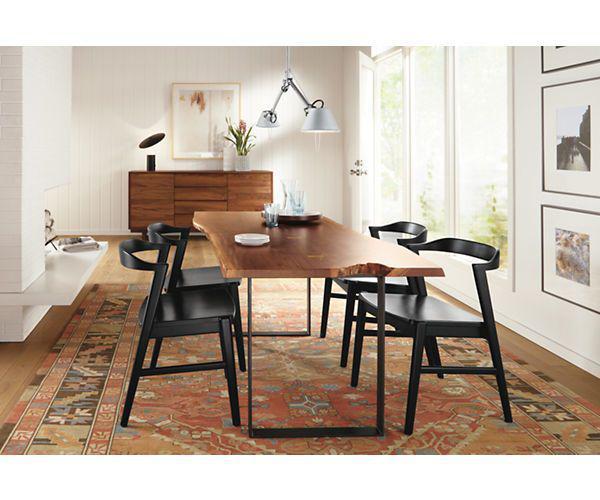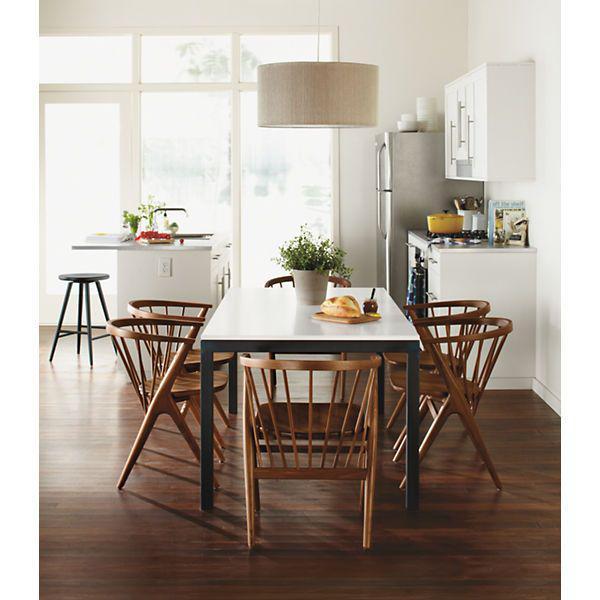The first image is the image on the left, the second image is the image on the right. Given the left and right images, does the statement "One long table is shown with four chairs and one with six chairs." hold true? Answer yes or no. Yes. 